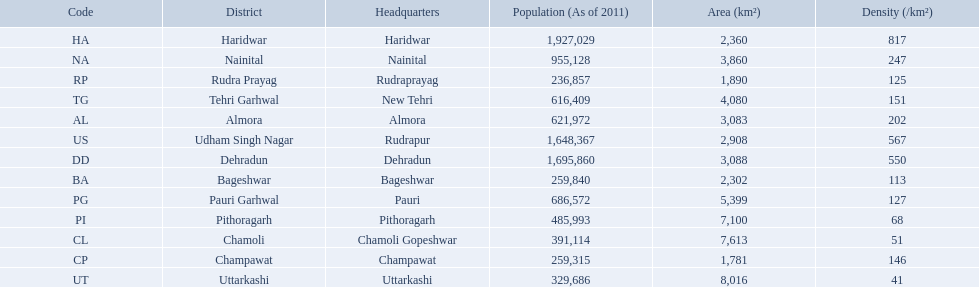What are all the districts? Almora, Bageshwar, Chamoli, Champawat, Dehradun, Haridwar, Nainital, Pauri Garhwal, Pithoragarh, Rudra Prayag, Tehri Garhwal, Udham Singh Nagar, Uttarkashi. And their densities? 202, 113, 51, 146, 550, 817, 247, 127, 68, 125, 151, 567, 41. Now, which district's density is 51? Chamoli. 